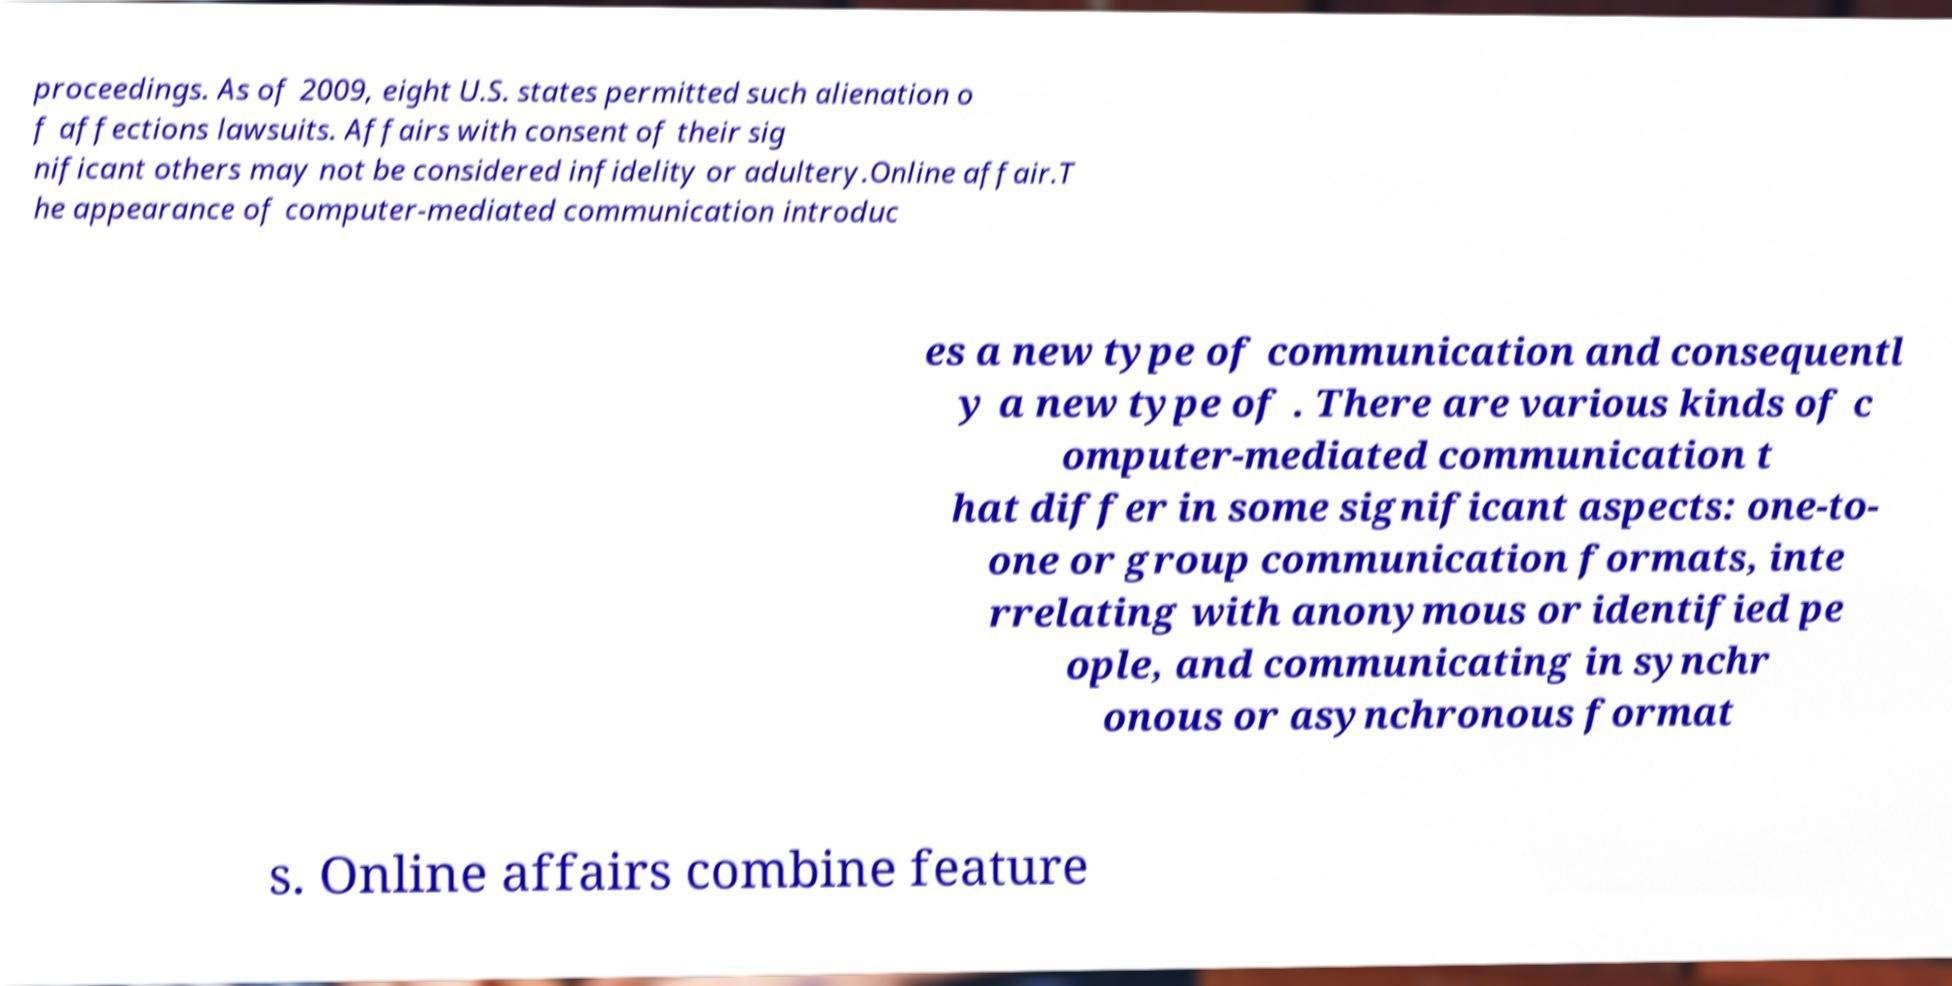Please read and relay the text visible in this image. What does it say? proceedings. As of 2009, eight U.S. states permitted such alienation o f affections lawsuits. Affairs with consent of their sig nificant others may not be considered infidelity or adultery.Online affair.T he appearance of computer-mediated communication introduc es a new type of communication and consequentl y a new type of . There are various kinds of c omputer-mediated communication t hat differ in some significant aspects: one-to- one or group communication formats, inte rrelating with anonymous or identified pe ople, and communicating in synchr onous or asynchronous format s. Online affairs combine feature 